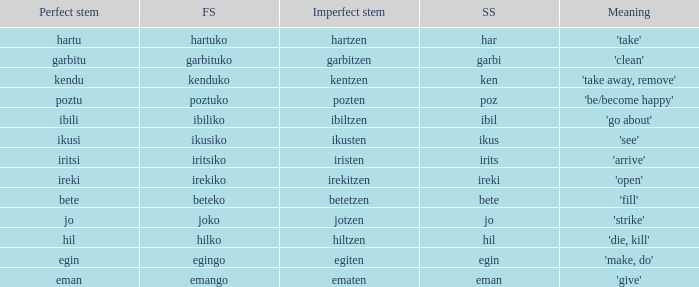What is the number for future stem for poztu? 1.0. 